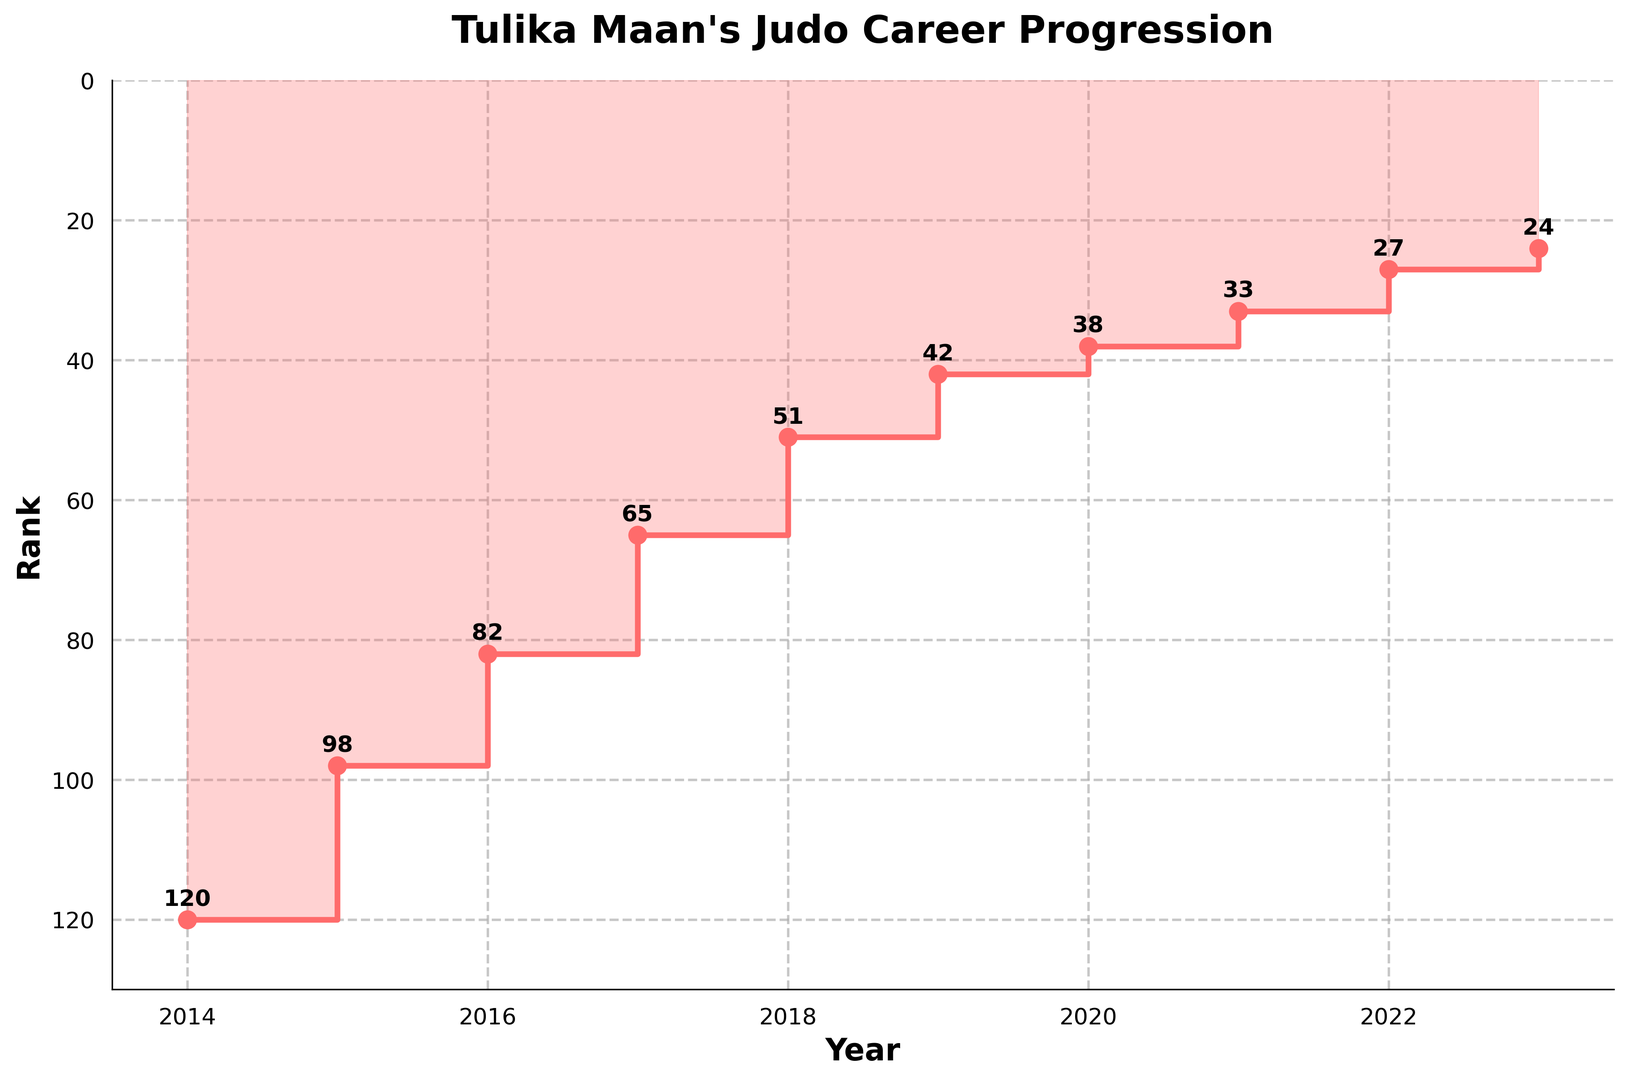What is the highest rank Tulika Maan achieved? The graph shows Tulika Maan's ranks over time. The lowest value (which is the highest rank) on the y-axis is 24 in the year 2023.
Answer: 24 How did Tulika Maan's rank change from 2014 to 2023? The rank values in 2014 and 2023 are 120 and 24, respectively. This indicates an improvement. She moved from 120 (lowest) to 24 (highest).
Answer: Improved from 120 to 24 Which year did Tulika Maan achieve a rank below 50 for the first time? The first point below the rank 50 line is in 2018, where her rank was 51 in 2017 and then 42 in 2019.
Answer: 2018 What is the average rank improvement per year from 2014 to 2023? Find the difference in rank values from 2014 to 2023 (120 - 24 = 96). Divide this by the number of years (2023 - 2014 = 9). The average rank improvement per year is 96 / 9 = 10.67.
Answer: 10.67 In which year did Tulika Maan make the largest improvement in rank? Compare year-over-year differences: 2014-2015: 22, 2015-2016: 16, 2016-2017: 17, 2017-2018: 14, 2018-2019: 9, 2019-2020: 4, 2020-2021: 5, 2021-2022: 6, 2022-2023: 3. The largest improvement was between 2014 and 2015 (22 ranks).
Answer: 2014 to 2015 What is the median rank over the years displayed? List ranks: 120, 98, 82, 65, 51, 42, 38, 33, 27, 24. The middle value in a sorted list is the median. With 10 values, the median is the average of 5th and 6th values (51 + 42) / 2 = 46.5.
Answer: 46.5 Compare Tulika Maan's rank improvement from the year just before the COVID-19 pandemic to the year of 2021. Her ranks in 2019, 2020, and 2021 are 42, 38, and 33 respectively. The improvement from 2019 to 2021 is 42 - 33 = 9 ranks.
Answer: 9 ranks Which year showed the smallest improvement in Tulika Maan's rank? Compare year-over-year differences to identify the smallest: 2014-2015: 22, 2015-2016: 16, 2016-2017: 17, 2017-2018: 14, 2018-2019: 9, 2019-2020: 4, 2020-2021: 5, 2021-2022: 6, 2022-2023: 3. 2022-2023 shows the smallest improvement of 3 ranks.
Answer: 2022 to 2023 Describe the overall trend in Tulika Maan’s rank progression from 2014 to 2023. The graph shows a consistent improvement in ranks over the years, indicated by a downward slope in the steps of the plot, moving from higher numbers (lower rank) to lower numbers (higher rank).
Answer: Consistent improvement 